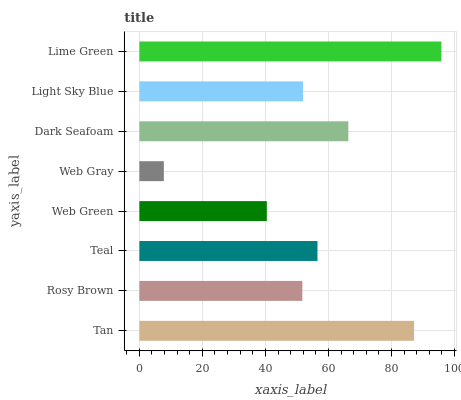Is Web Gray the minimum?
Answer yes or no. Yes. Is Lime Green the maximum?
Answer yes or no. Yes. Is Rosy Brown the minimum?
Answer yes or no. No. Is Rosy Brown the maximum?
Answer yes or no. No. Is Tan greater than Rosy Brown?
Answer yes or no. Yes. Is Rosy Brown less than Tan?
Answer yes or no. Yes. Is Rosy Brown greater than Tan?
Answer yes or no. No. Is Tan less than Rosy Brown?
Answer yes or no. No. Is Teal the high median?
Answer yes or no. Yes. Is Light Sky Blue the low median?
Answer yes or no. Yes. Is Dark Seafoam the high median?
Answer yes or no. No. Is Dark Seafoam the low median?
Answer yes or no. No. 